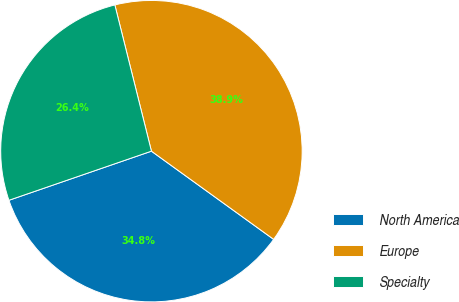Convert chart to OTSL. <chart><loc_0><loc_0><loc_500><loc_500><pie_chart><fcel>North America<fcel>Europe<fcel>Specialty<nl><fcel>34.77%<fcel>38.85%<fcel>26.38%<nl></chart> 